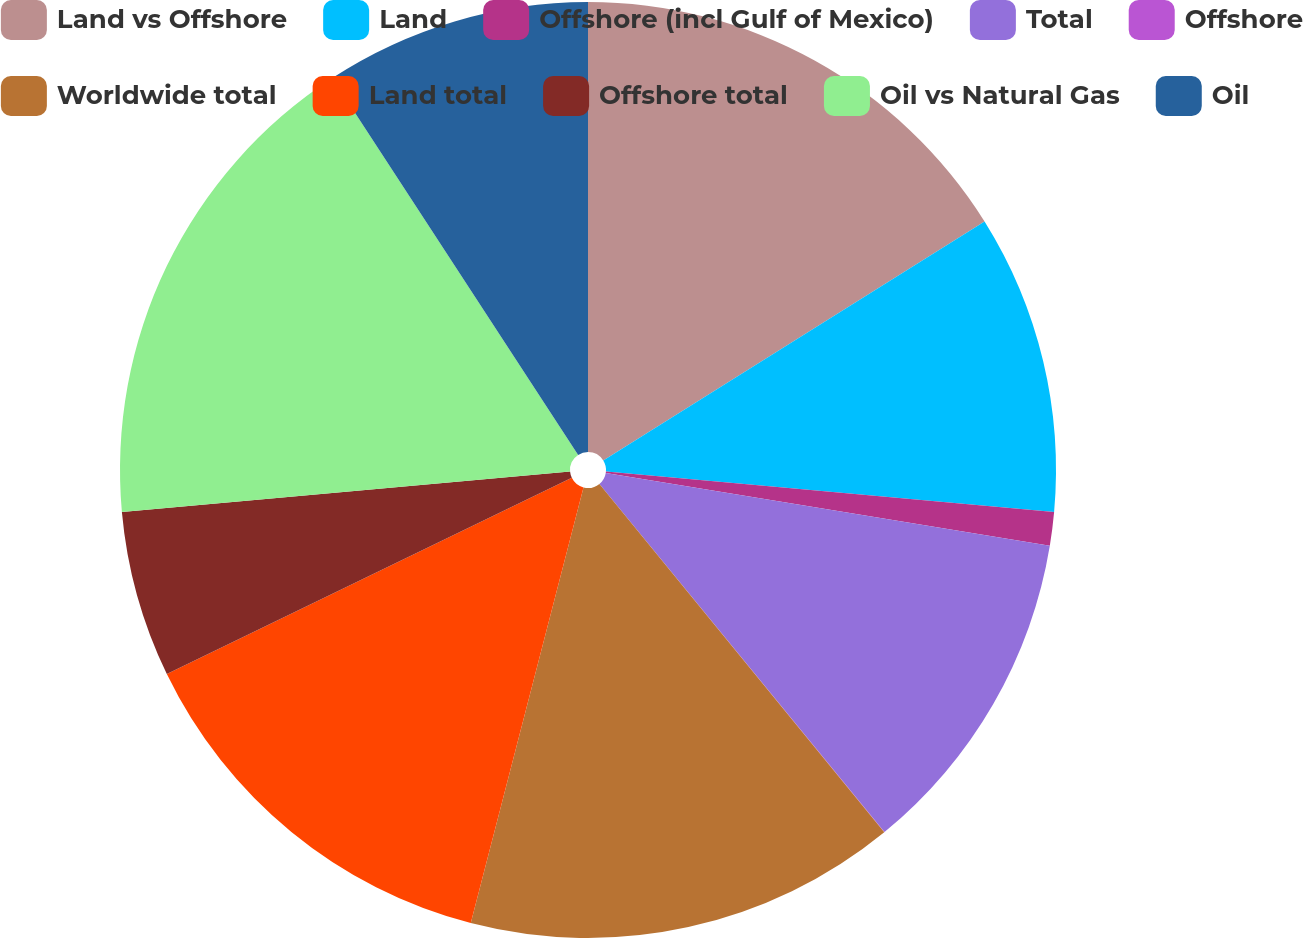<chart> <loc_0><loc_0><loc_500><loc_500><pie_chart><fcel>Land vs Offshore<fcel>Land<fcel>Offshore (incl Gulf of Mexico)<fcel>Total<fcel>Offshore<fcel>Worldwide total<fcel>Land total<fcel>Offshore total<fcel>Oil vs Natural Gas<fcel>Oil<nl><fcel>16.09%<fcel>10.34%<fcel>1.16%<fcel>11.49%<fcel>0.01%<fcel>14.94%<fcel>13.79%<fcel>5.75%<fcel>17.23%<fcel>9.2%<nl></chart> 